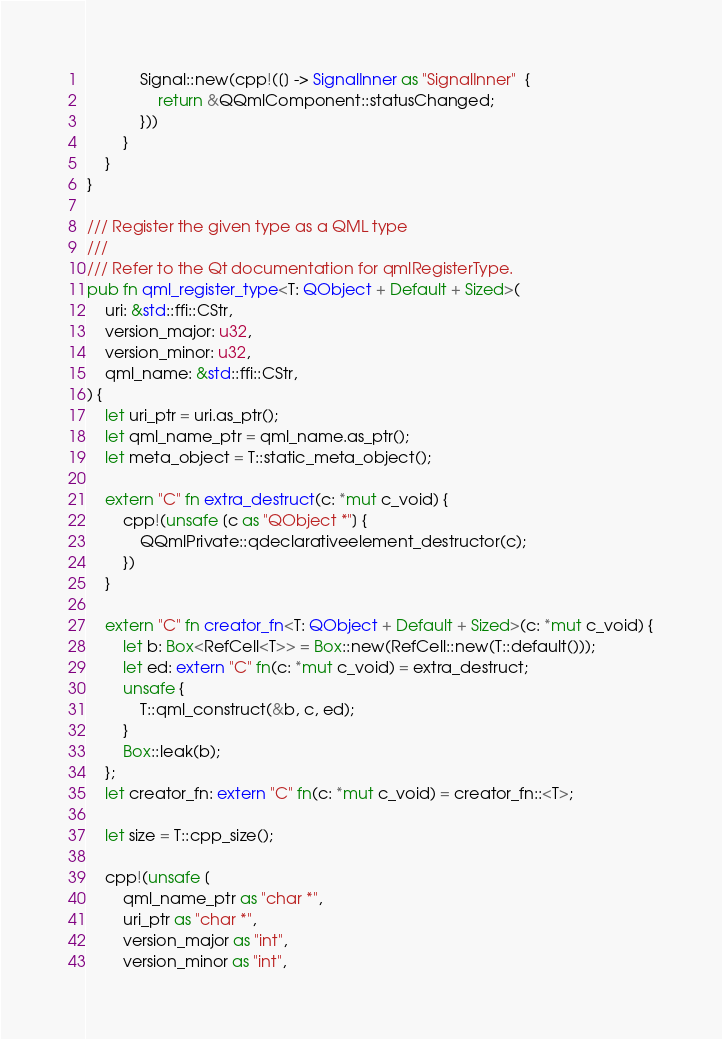Convert code to text. <code><loc_0><loc_0><loc_500><loc_500><_Rust_>            Signal::new(cpp!([] -> SignalInner as "SignalInner"  {
                return &QQmlComponent::statusChanged;
            }))
        }
    }
}

/// Register the given type as a QML type
///
/// Refer to the Qt documentation for qmlRegisterType.
pub fn qml_register_type<T: QObject + Default + Sized>(
    uri: &std::ffi::CStr,
    version_major: u32,
    version_minor: u32,
    qml_name: &std::ffi::CStr,
) {
    let uri_ptr = uri.as_ptr();
    let qml_name_ptr = qml_name.as_ptr();
    let meta_object = T::static_meta_object();

    extern "C" fn extra_destruct(c: *mut c_void) {
        cpp!(unsafe [c as "QObject *"] {
            QQmlPrivate::qdeclarativeelement_destructor(c);
        })
    }

    extern "C" fn creator_fn<T: QObject + Default + Sized>(c: *mut c_void) {
        let b: Box<RefCell<T>> = Box::new(RefCell::new(T::default()));
        let ed: extern "C" fn(c: *mut c_void) = extra_destruct;
        unsafe {
            T::qml_construct(&b, c, ed);
        }
        Box::leak(b);
    };
    let creator_fn: extern "C" fn(c: *mut c_void) = creator_fn::<T>;

    let size = T::cpp_size();

    cpp!(unsafe [
        qml_name_ptr as "char *",
        uri_ptr as "char *",
        version_major as "int",
        version_minor as "int",</code> 